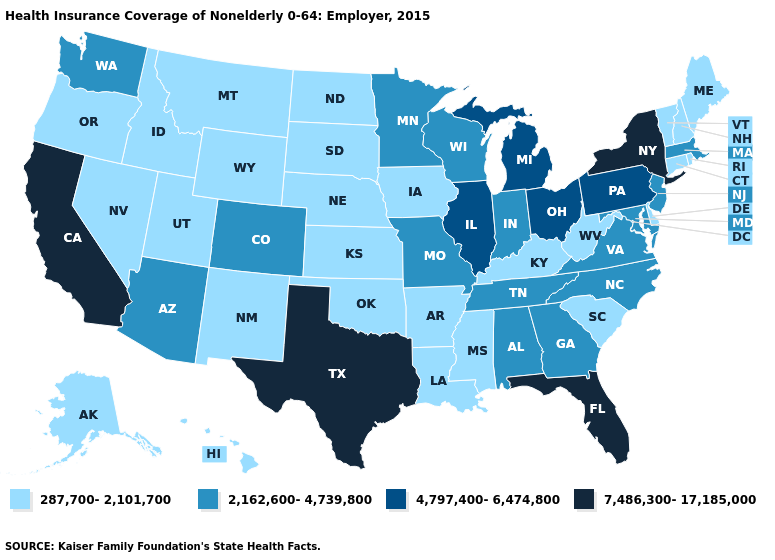What is the highest value in the MidWest ?
Short answer required. 4,797,400-6,474,800. What is the lowest value in the MidWest?
Concise answer only. 287,700-2,101,700. Among the states that border New York , which have the lowest value?
Be succinct. Connecticut, Vermont. Among the states that border Missouri , which have the lowest value?
Be succinct. Arkansas, Iowa, Kansas, Kentucky, Nebraska, Oklahoma. What is the value of Arkansas?
Keep it brief. 287,700-2,101,700. Name the states that have a value in the range 2,162,600-4,739,800?
Keep it brief. Alabama, Arizona, Colorado, Georgia, Indiana, Maryland, Massachusetts, Minnesota, Missouri, New Jersey, North Carolina, Tennessee, Virginia, Washington, Wisconsin. Does Vermont have the highest value in the Northeast?
Give a very brief answer. No. Name the states that have a value in the range 4,797,400-6,474,800?
Concise answer only. Illinois, Michigan, Ohio, Pennsylvania. How many symbols are there in the legend?
Write a very short answer. 4. What is the highest value in the USA?
Concise answer only. 7,486,300-17,185,000. What is the value of Pennsylvania?
Answer briefly. 4,797,400-6,474,800. What is the highest value in the USA?
Give a very brief answer. 7,486,300-17,185,000. What is the lowest value in the USA?
Keep it brief. 287,700-2,101,700. Name the states that have a value in the range 7,486,300-17,185,000?
Keep it brief. California, Florida, New York, Texas. Among the states that border South Dakota , which have the highest value?
Keep it brief. Minnesota. 